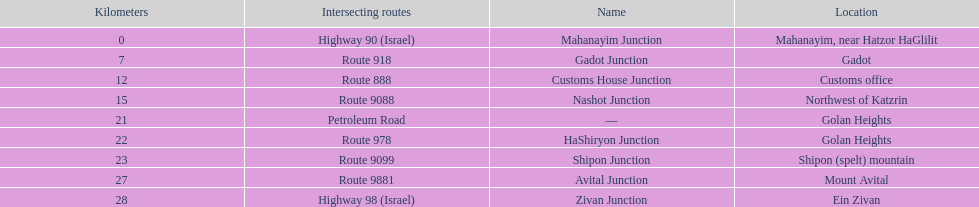What junction is the furthest from mahanayim junction? Zivan Junction. 